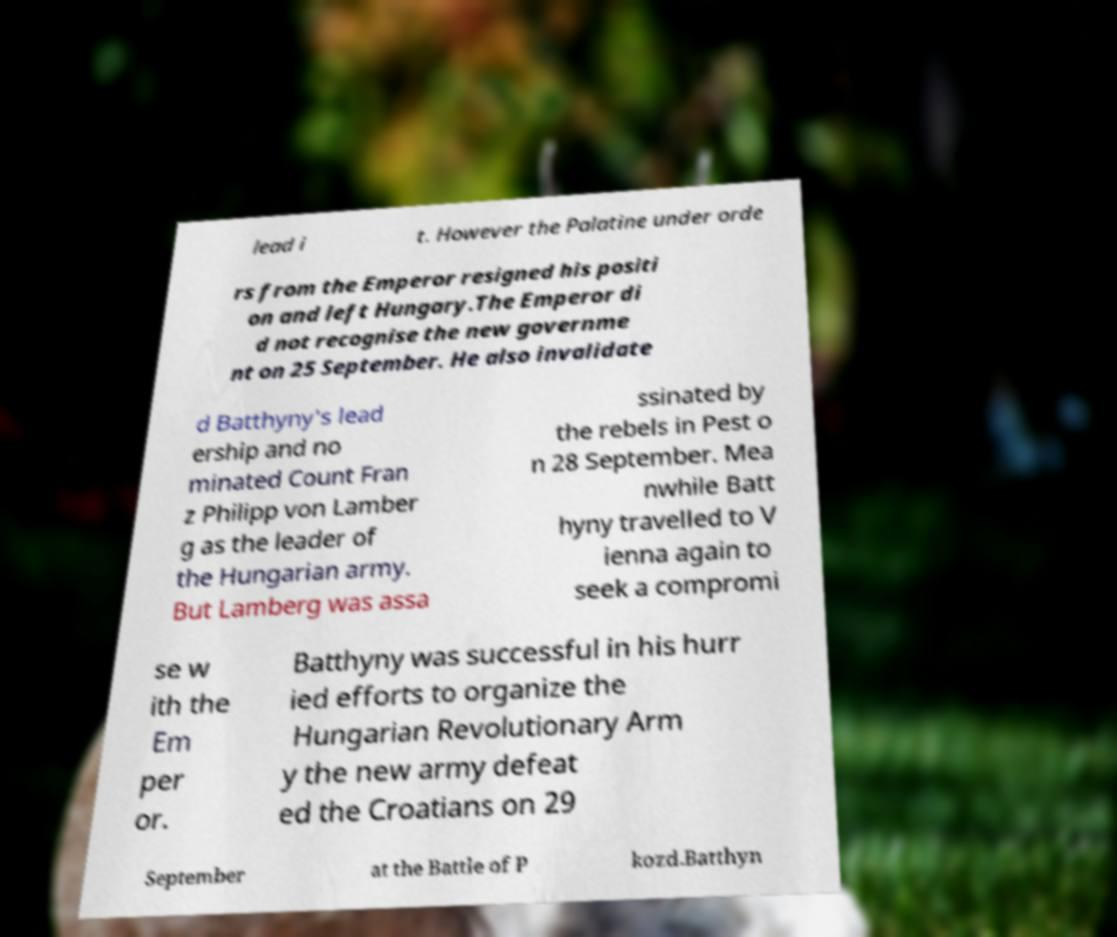I need the written content from this picture converted into text. Can you do that? lead i t. However the Palatine under orde rs from the Emperor resigned his positi on and left Hungary.The Emperor di d not recognise the new governme nt on 25 September. He also invalidate d Batthyny's lead ership and no minated Count Fran z Philipp von Lamber g as the leader of the Hungarian army. But Lamberg was assa ssinated by the rebels in Pest o n 28 September. Mea nwhile Batt hyny travelled to V ienna again to seek a compromi se w ith the Em per or. Batthyny was successful in his hurr ied efforts to organize the Hungarian Revolutionary Arm y the new army defeat ed the Croatians on 29 September at the Battle of P kozd.Batthyn 